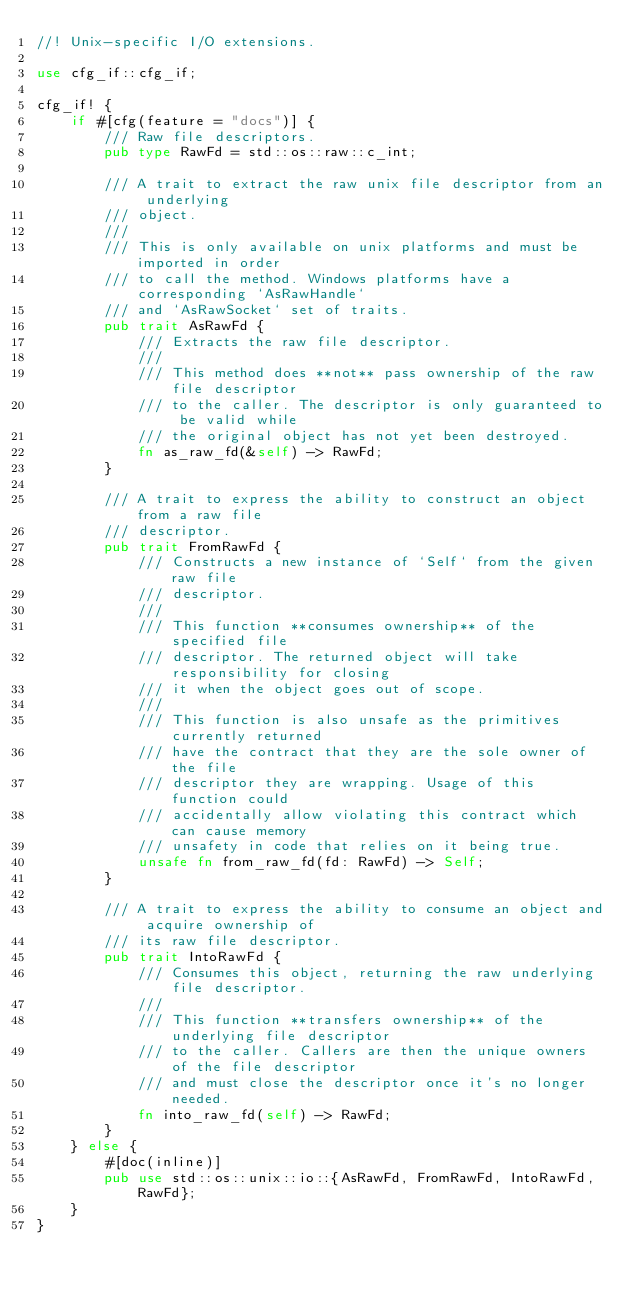<code> <loc_0><loc_0><loc_500><loc_500><_Rust_>//! Unix-specific I/O extensions.

use cfg_if::cfg_if;

cfg_if! {
    if #[cfg(feature = "docs")] {
        /// Raw file descriptors.
        pub type RawFd = std::os::raw::c_int;

        /// A trait to extract the raw unix file descriptor from an underlying
        /// object.
        ///
        /// This is only available on unix platforms and must be imported in order
        /// to call the method. Windows platforms have a corresponding `AsRawHandle`
        /// and `AsRawSocket` set of traits.
        pub trait AsRawFd {
            /// Extracts the raw file descriptor.
            ///
            /// This method does **not** pass ownership of the raw file descriptor
            /// to the caller. The descriptor is only guaranteed to be valid while
            /// the original object has not yet been destroyed.
            fn as_raw_fd(&self) -> RawFd;
        }

        /// A trait to express the ability to construct an object from a raw file
        /// descriptor.
        pub trait FromRawFd {
            /// Constructs a new instance of `Self` from the given raw file
            /// descriptor.
            ///
            /// This function **consumes ownership** of the specified file
            /// descriptor. The returned object will take responsibility for closing
            /// it when the object goes out of scope.
            ///
            /// This function is also unsafe as the primitives currently returned
            /// have the contract that they are the sole owner of the file
            /// descriptor they are wrapping. Usage of this function could
            /// accidentally allow violating this contract which can cause memory
            /// unsafety in code that relies on it being true.
            unsafe fn from_raw_fd(fd: RawFd) -> Self;
        }

        /// A trait to express the ability to consume an object and acquire ownership of
        /// its raw file descriptor.
        pub trait IntoRawFd {
            /// Consumes this object, returning the raw underlying file descriptor.
            ///
            /// This function **transfers ownership** of the underlying file descriptor
            /// to the caller. Callers are then the unique owners of the file descriptor
            /// and must close the descriptor once it's no longer needed.
            fn into_raw_fd(self) -> RawFd;
        }
    } else {
        #[doc(inline)]
        pub use std::os::unix::io::{AsRawFd, FromRawFd, IntoRawFd, RawFd};
    }
}
</code> 